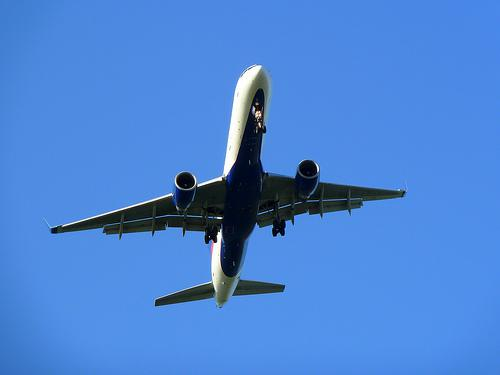Question: what color is the sky?
Choices:
A. Green.
B. Yellow.
C. Blue.
D. Orange.
Answer with the letter. Answer: C Question: when was this photo taken?
Choices:
A. At dawn.
B. At dusk.
C. In the storm.
D. Daytime.
Answer with the letter. Answer: D Question: who is the pilot of this plane?
Choices:
A. It is impossible to know this.
B. Robert Redford.
C. Sean Penn.
D. Harrison Ford.
Answer with the letter. Answer: A 